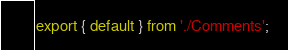Convert code to text. <code><loc_0><loc_0><loc_500><loc_500><_JavaScript_>export { default } from './Comments';
</code> 